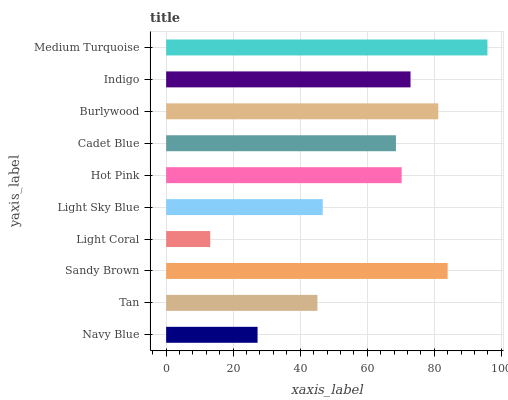Is Light Coral the minimum?
Answer yes or no. Yes. Is Medium Turquoise the maximum?
Answer yes or no. Yes. Is Tan the minimum?
Answer yes or no. No. Is Tan the maximum?
Answer yes or no. No. Is Tan greater than Navy Blue?
Answer yes or no. Yes. Is Navy Blue less than Tan?
Answer yes or no. Yes. Is Navy Blue greater than Tan?
Answer yes or no. No. Is Tan less than Navy Blue?
Answer yes or no. No. Is Hot Pink the high median?
Answer yes or no. Yes. Is Cadet Blue the low median?
Answer yes or no. Yes. Is Indigo the high median?
Answer yes or no. No. Is Burlywood the low median?
Answer yes or no. No. 